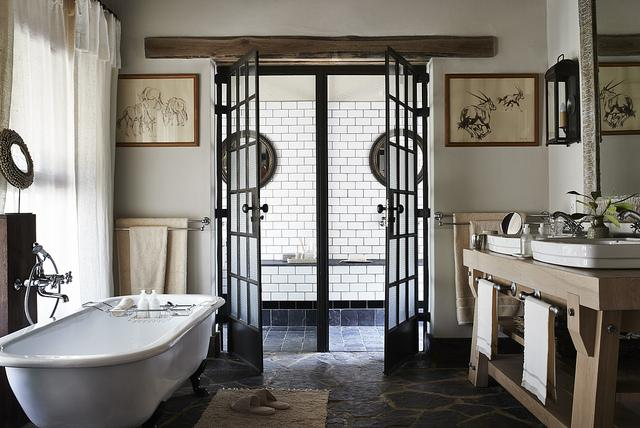The floor of the bathroom is made of what material?

Choices:
A) carpet
B) wood
C) vinyl
D) stone stone 